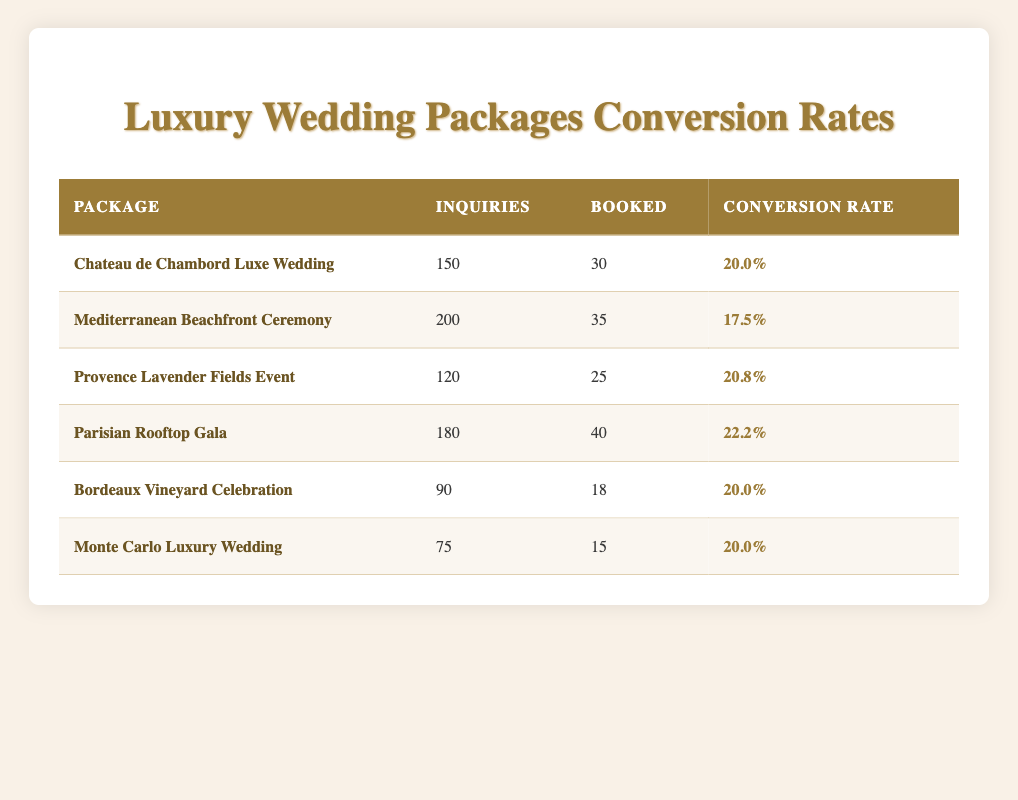What is the conversion rate for the Mediterranean Beachfront Ceremony package? The table shows that the conversion rate for the Mediterranean Beachfront Ceremony package is listed directly as 17.5%.
Answer: 17.5% Which wedding package had the highest number of inquiries? According to the table, the Mediterranean Beachfront Ceremony package had the highest inquiries with a total of 200.
Answer: 200 What is the average conversion rate for all packages listed in the table? To find the average conversion rate, sum the conversion rates (20.0 + 17.5 + 20.8 + 22.2 + 20.0 + 20.0 = 120.5) and divide by the number of packages (6). So, 120.5 / 6 = 20.08.
Answer: 20.08 Are there any packages with a conversion rate of 22% or higher? By examining the conversion rates listed in the table, we see that only the Parisian Rooftop Gala has a conversion rate of 22.2%, which is indeed 22% or higher.
Answer: Yes How many total inquiries were made across all packages? To find the total inquiries, sum the inquiries column: 150 + 200 + 120 + 180 + 90 + 75 = 915.
Answer: 915 Which package has the lowest conversion rate and what is that rate? The Mediterranean Beachfront Ceremony has the lowest conversion rate of 17.5%, as it is the only one below 20%.
Answer: 17.5% What is the difference in booked weddings between the Parisian Rooftop Gala and the Monte Carlo Luxury Wedding? The Parisian Rooftop Gala had 40 bookings, while the Monte Carlo Luxury Wedding had 15. Thus, the difference is 40 - 15 = 25.
Answer: 25 Which package had the highest number of weddings booked? From the data, the Parisian Rooftop Gala had the highest bookings with a total of 40.
Answer: 40 How does the conversion rate of the Provence Lavender Fields Event compare with the Monte Carlo Luxury Wedding? The Provence Lavender Fields Event had a conversion rate of 20.8%, which is higher than the Monte Carlo Luxury Wedding's conversion rate of 20.0%.
Answer: Higher 